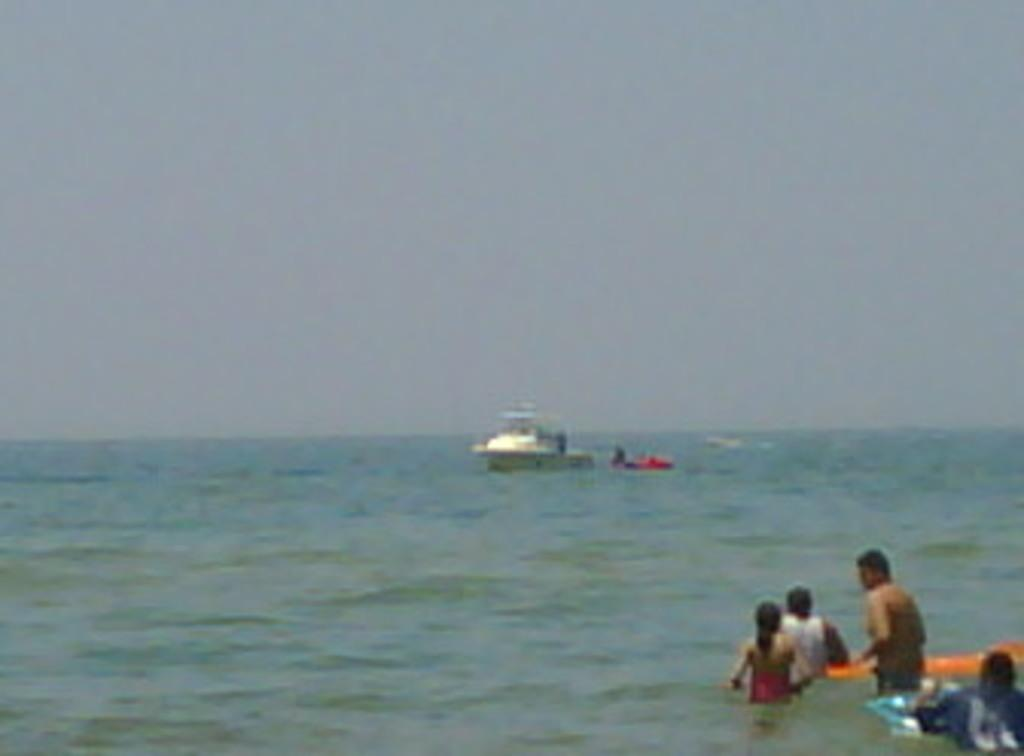What is the main subject of the image? The main subject of the image is a motor boat. Where is the motor boat located? The motor boat is on the water. Are there any people present in the image? Yes, there are people standing in the water. What type of mountain can be seen in the background of the image? There is no mountain present in the image; it features a motor boat on the water with people standing nearby. 